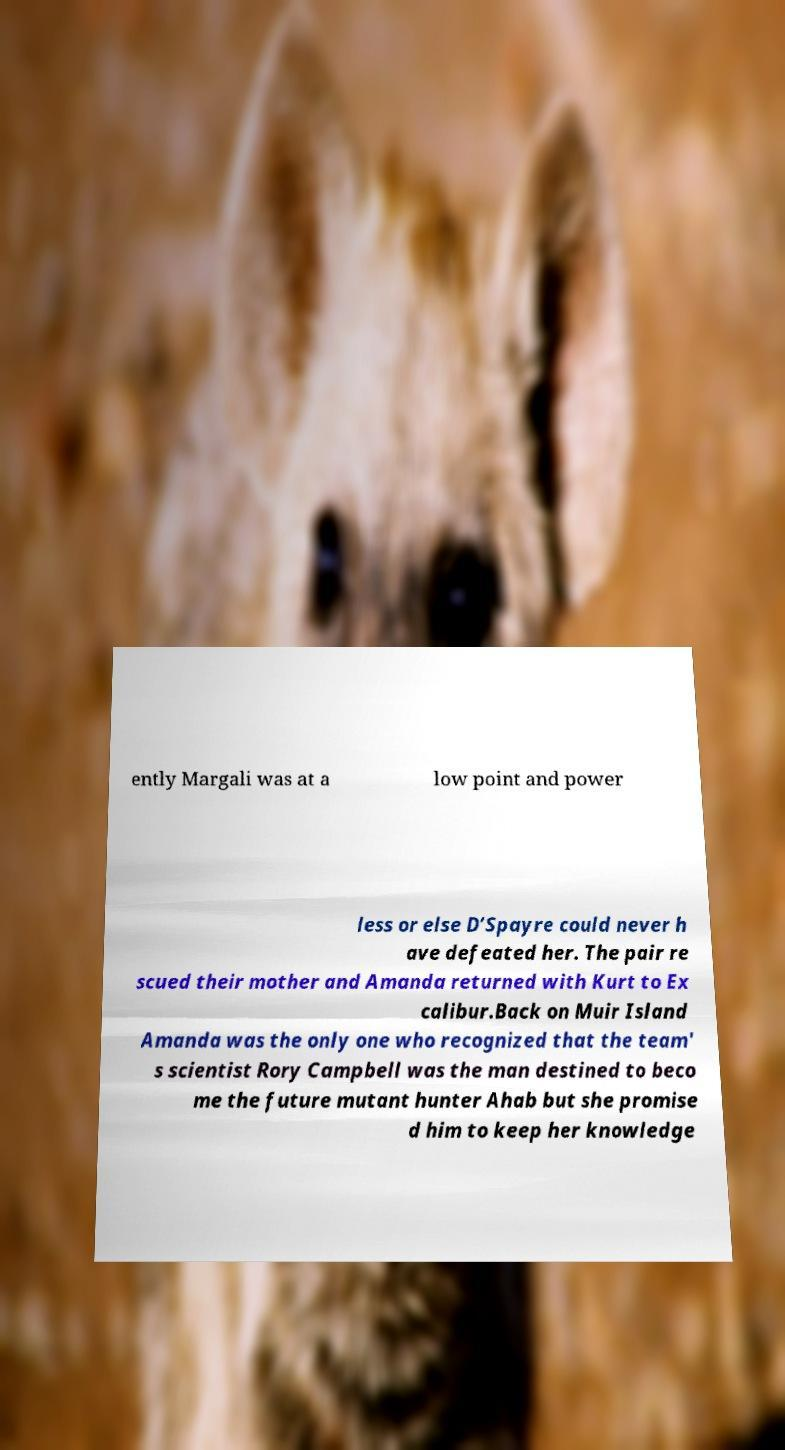Can you read and provide the text displayed in the image?This photo seems to have some interesting text. Can you extract and type it out for me? ently Margali was at a low point and power less or else D’Spayre could never h ave defeated her. The pair re scued their mother and Amanda returned with Kurt to Ex calibur.Back on Muir Island Amanda was the only one who recognized that the team' s scientist Rory Campbell was the man destined to beco me the future mutant hunter Ahab but she promise d him to keep her knowledge 